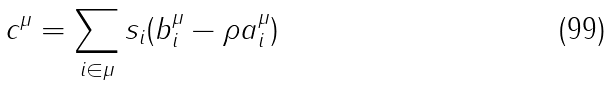<formula> <loc_0><loc_0><loc_500><loc_500>c ^ { \mu } = \sum _ { i \in \mu } s _ { i } ( b _ { i } ^ { \mu } - \rho a _ { i } ^ { \mu } )</formula> 